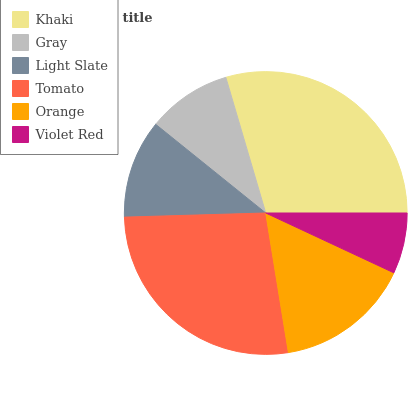Is Violet Red the minimum?
Answer yes or no. Yes. Is Khaki the maximum?
Answer yes or no. Yes. Is Gray the minimum?
Answer yes or no. No. Is Gray the maximum?
Answer yes or no. No. Is Khaki greater than Gray?
Answer yes or no. Yes. Is Gray less than Khaki?
Answer yes or no. Yes. Is Gray greater than Khaki?
Answer yes or no. No. Is Khaki less than Gray?
Answer yes or no. No. Is Orange the high median?
Answer yes or no. Yes. Is Light Slate the low median?
Answer yes or no. Yes. Is Khaki the high median?
Answer yes or no. No. Is Tomato the low median?
Answer yes or no. No. 